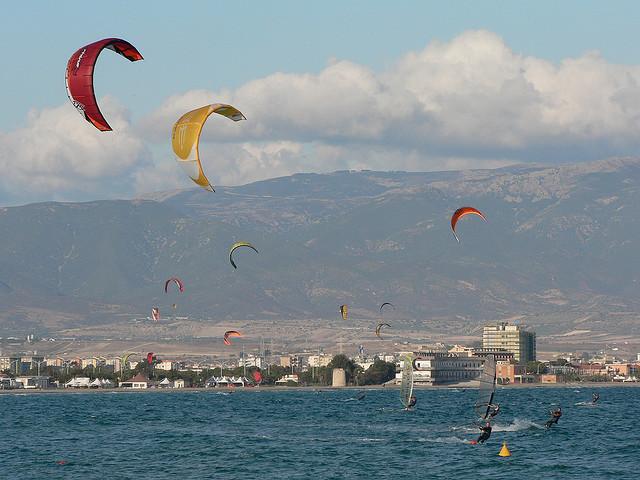What type of clouds are in the sky?
Concise answer only. Cumulus. Is it a sunny day?
Concise answer only. Yes. What is the more predominant color of sails?
Give a very brief answer. Red. 